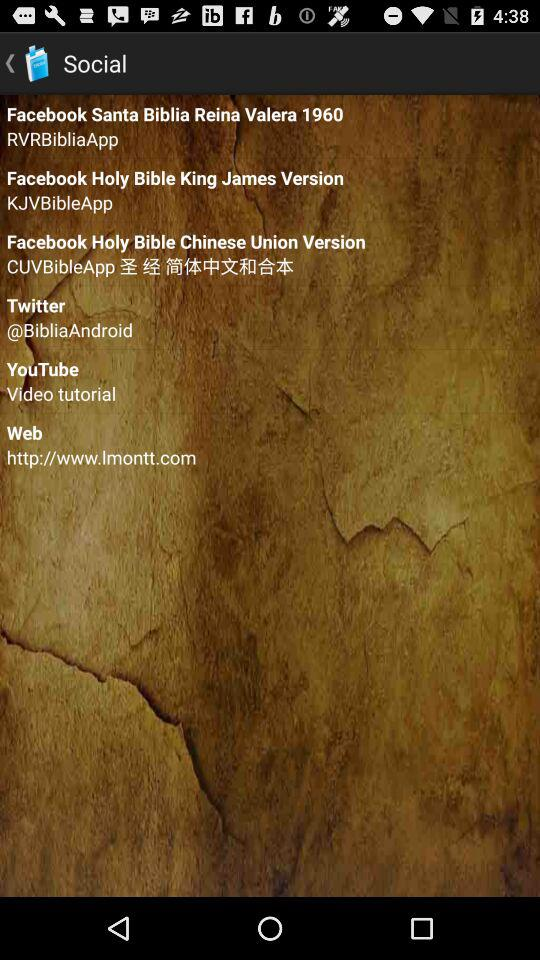What is the version of facebook holy bible king?
When the provided information is insufficient, respond with <no answer>. <no answer> 